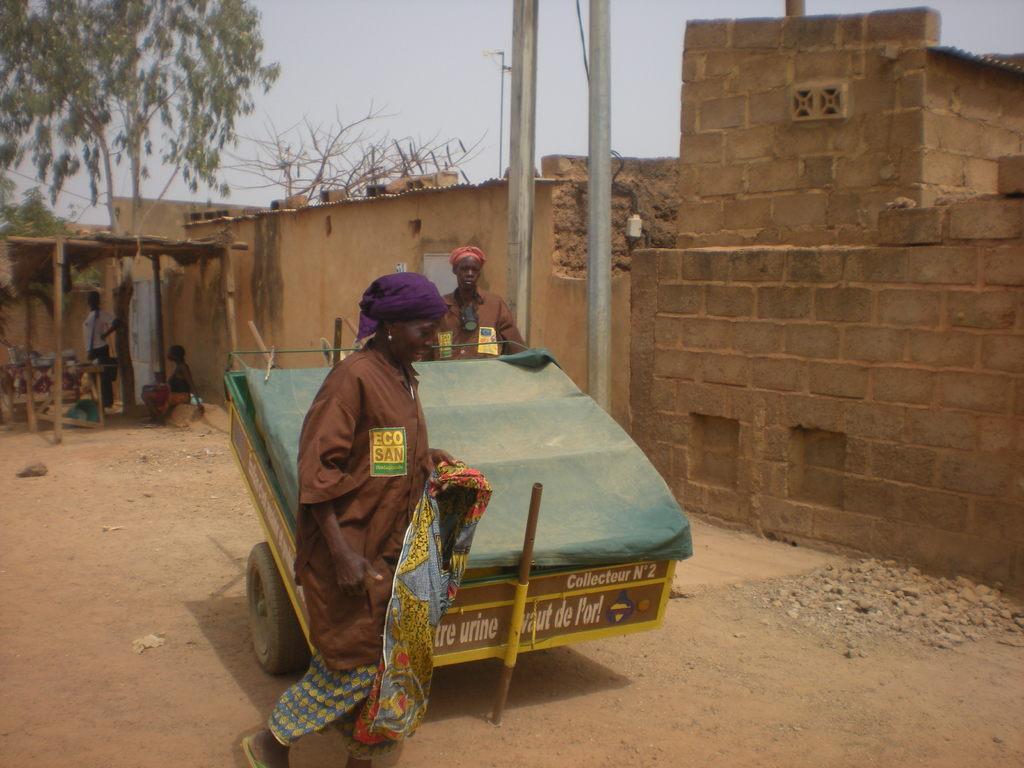Describe this image in one or two sentences. In the image there is a vehicle and there are two people around that vehicle, on the right side there is a wall and in the background there are some people under a shelter, behind that there is a tree. 